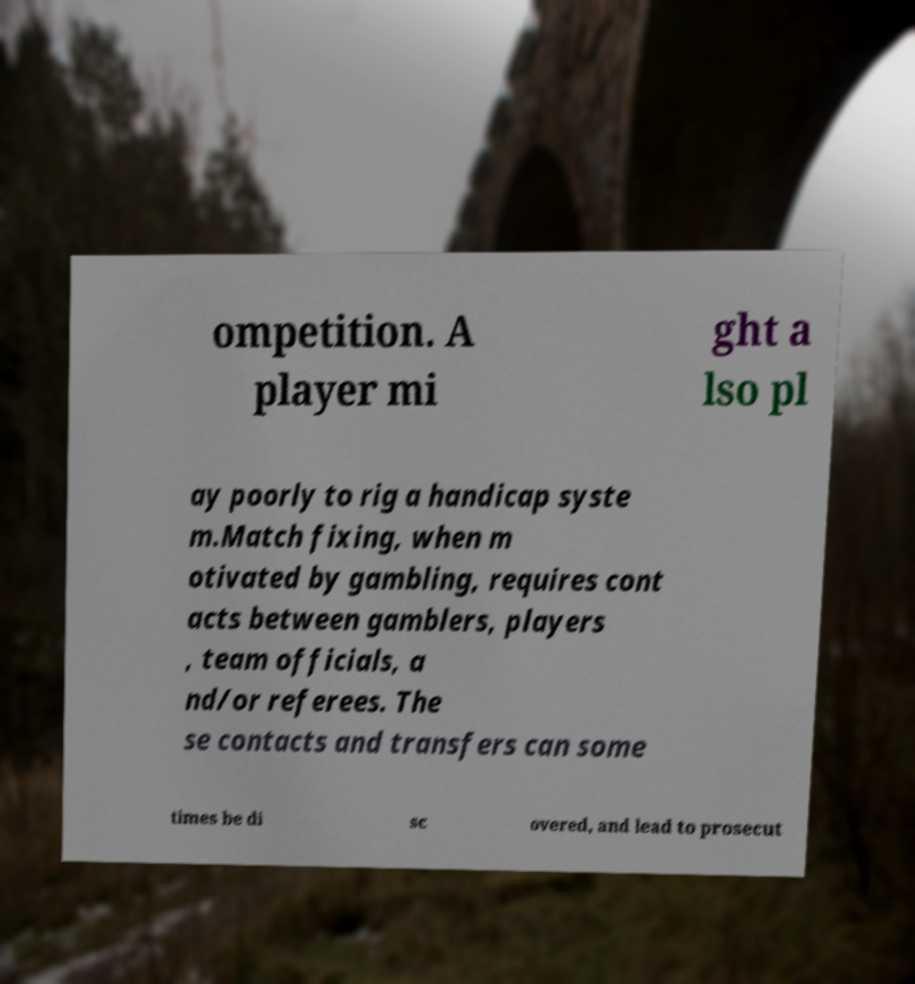For documentation purposes, I need the text within this image transcribed. Could you provide that? ompetition. A player mi ght a lso pl ay poorly to rig a handicap syste m.Match fixing, when m otivated by gambling, requires cont acts between gamblers, players , team officials, a nd/or referees. The se contacts and transfers can some times be di sc overed, and lead to prosecut 